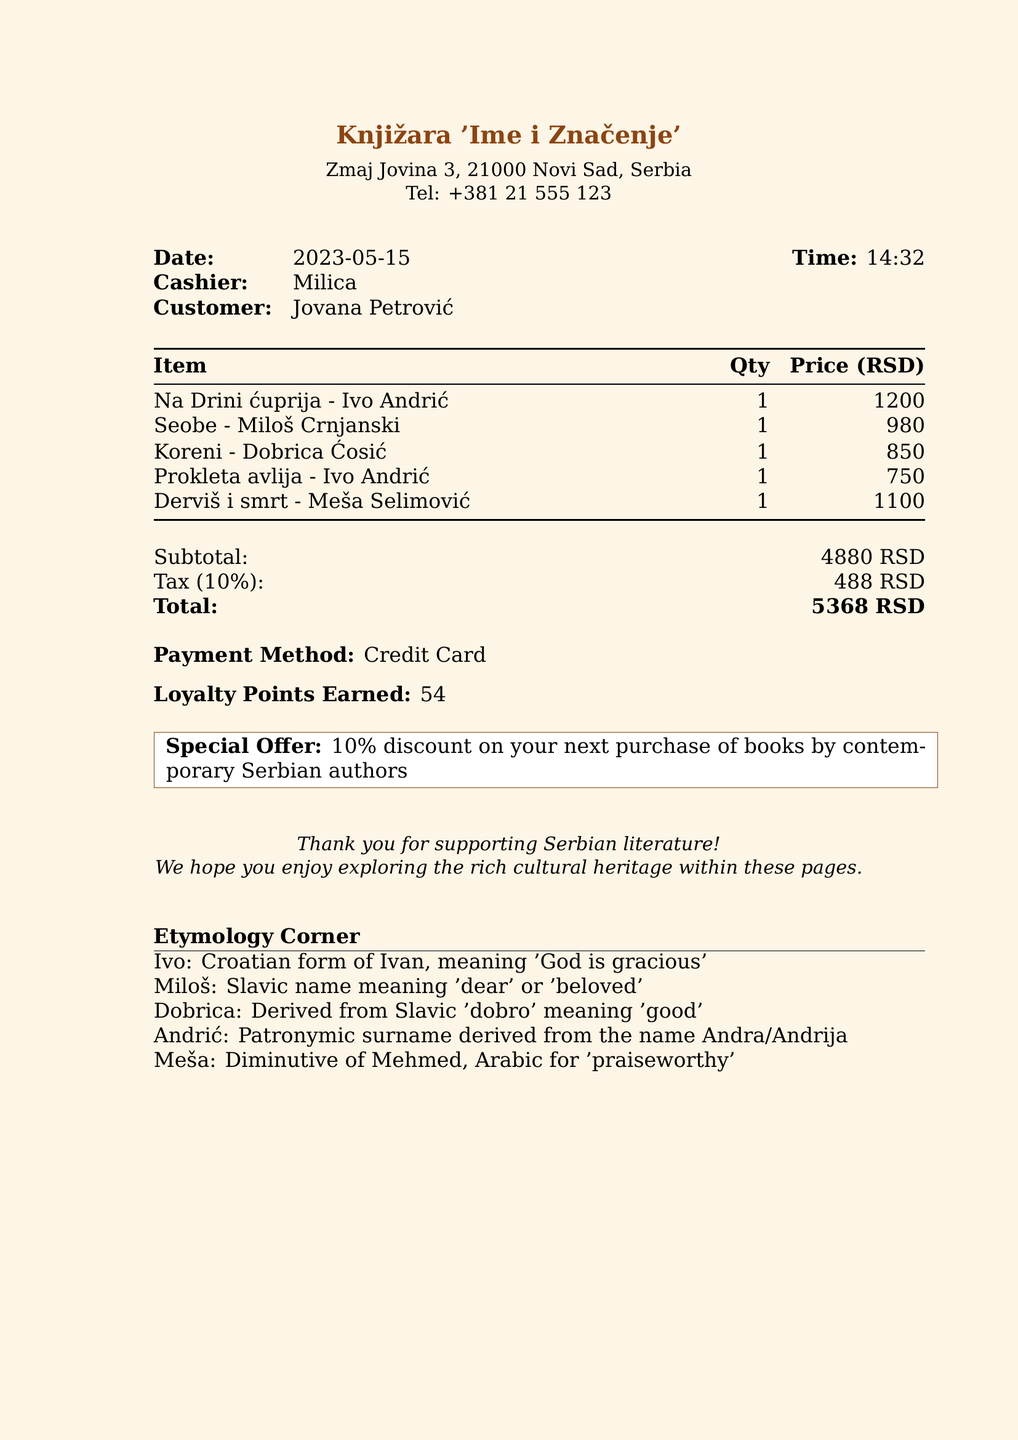What is the store name? The store name is mentioned at the top of the receipt.
Answer: Knjižara 'Ime i Značenje' Who was the cashier for this transaction? The cashier's name is provided in the receipt details.
Answer: Milica What is the total amount charged? The total amount is calculated as the subtotal plus tax and presented at the bottom of the receipt.
Answer: 5368 RSD How many loyalty points were earned? The receipt includes a specific mention of the loyalty points earned from this purchase.
Answer: 54 What is the title of the first book listed? The first book title appears at the beginning of the list of items.
Answer: Na Drini ćuprija What does the name "Ivo" mean? The etymology section provides the meaning of the name "Ivo."
Answer: God is gracious How much is the tax amount? The tax amount is explicitly stated in the calculation portion of the receipt.
Answer: 488 RSD Which author appears twice in the receipt? By checking the author names listed, we can identify one that is mentioned more than once.
Answer: Ivo Andrić What is the special offer mentioned? The details of the special offer are presented in a highlighted section of the receipt.
Answer: 10% discount on your next purchase of books by contemporary Serbian authors 